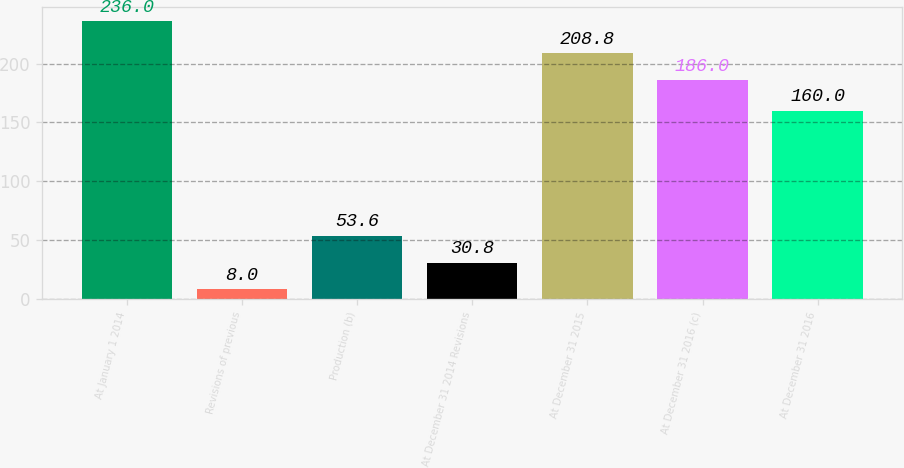<chart> <loc_0><loc_0><loc_500><loc_500><bar_chart><fcel>At January 1 2014<fcel>Revisions of previous<fcel>Production (b)<fcel>At December 31 2014 Revisions<fcel>At December 31 2015<fcel>At December 31 2016 (c)<fcel>At December 31 2016<nl><fcel>236<fcel>8<fcel>53.6<fcel>30.8<fcel>208.8<fcel>186<fcel>160<nl></chart> 